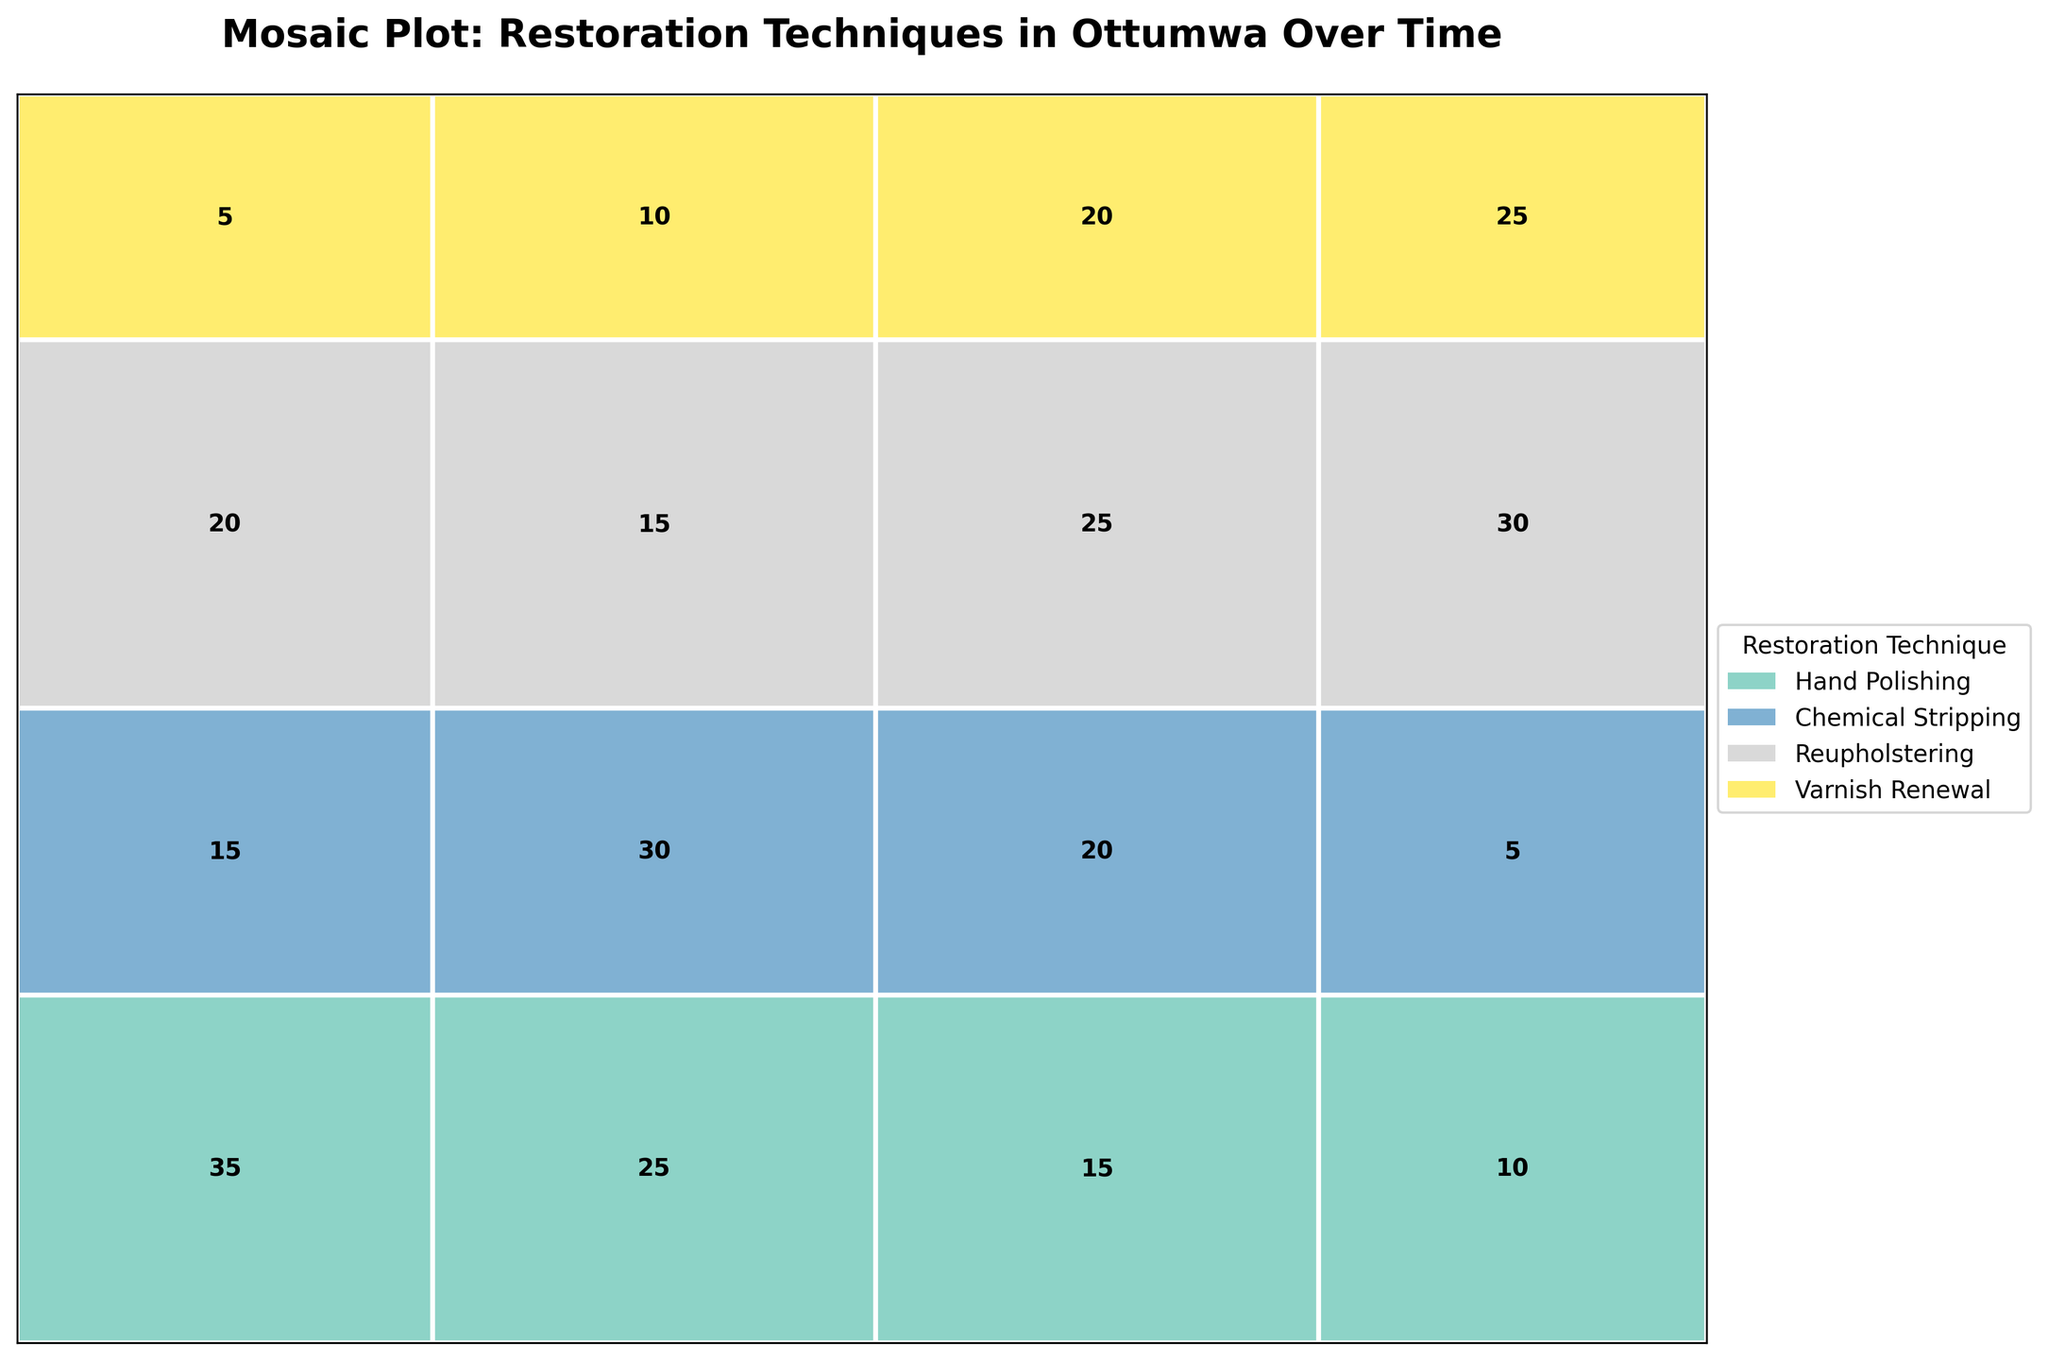How many restoration techniques are displayed in the plot? The plot has a legend displaying different colors, each representing a unique restoration technique. By counting these, you can determine the total number of restoration techniques.
Answer: 4 Which time period had the highest total number of restorations? By evaluating the annotations in each section of the Mosaic Plot, you see that the frequencies for each time period are summed. The time period with the highest total indicates the highest number of restorations.
Answer: 1981-2010 Which restoration technique was least used in the 1951-1980 period? Analyzing the counts within the 1951-1980 section, you find the restoration technique with the lowest frequency.
Answer: Reupholstering How does the frequency of Hand Polishing in the 1920-1950 period compare to the 2011-Present period? Compare the frequency annotation for Hand Polishing in the 1920-1950 period with the frequency annotation for the same technique in the 2011-Present period.
Answer: Higher in 1920-1950 What is the most common restoration technique used on Glassware in the 2011-Present period? Focus on the Glassware section of the 2011-Present period and look for the highest frequency among the restoration techniques applied to Glassware.
Answer: Varnish Renewal How did the frequency of Chemical Stripping change from 1951-1980 to 1981-2010? Compare the frequency counts of Chemical Stripping in the periods 1951-1980 and 1981-2010, and note the difference.
Answer: Decreased by 10 Which restoration technique showed a consistent increase in frequency across all periods? Examine each restoration technique across all periods and identify any that show an increasing frequency trend.
Answer: Reupholstering What is the total frequency of restorations done between 1981-2010? Sum the frequencies of all restoration techniques during the period 1981-2010 by checking the annotations in this section.
Answer: 80 Did Hand Polishing see a significant change in frequency from 1920-1950 to 1951-1980? Compare the counts of Hand Polishing for these two periods and determine the difference.
Answer: Decreased by 10 Which time period had the lowest total frequency for Varnish Renewal? Focus on the frequencies of Varnish Renewal across all time periods and identify the period with the lowest count.
Answer: 1920-1950 